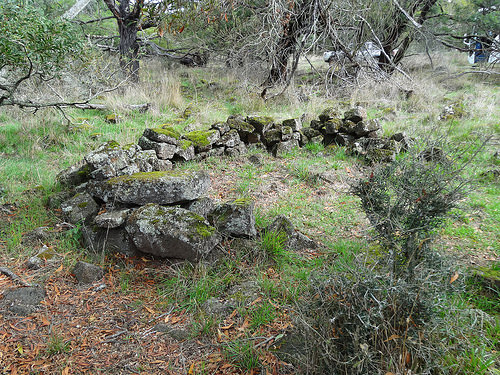<image>
Can you confirm if the rock is next to the ground? No. The rock is not positioned next to the ground. They are located in different areas of the scene. Is there a rock in front of the tree? Yes. The rock is positioned in front of the tree, appearing closer to the camera viewpoint. 